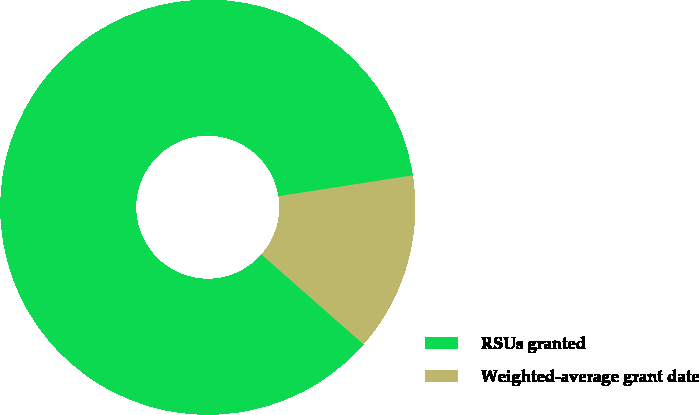Convert chart to OTSL. <chart><loc_0><loc_0><loc_500><loc_500><pie_chart><fcel>RSUs granted<fcel>Weighted-average grant date<nl><fcel>86.07%<fcel>13.93%<nl></chart> 